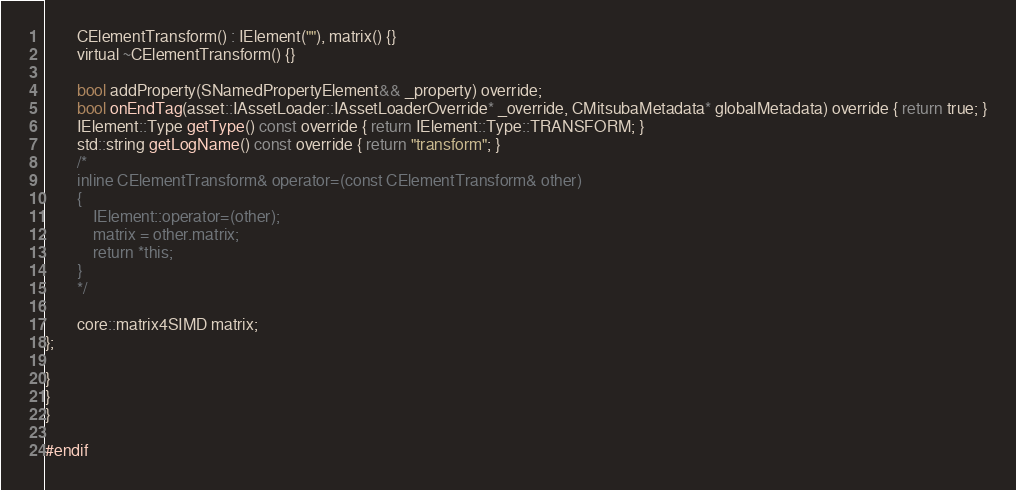<code> <loc_0><loc_0><loc_500><loc_500><_C_>		CElementTransform() : IElement(""), matrix() {}
		virtual ~CElementTransform() {}

		bool addProperty(SNamedPropertyElement&& _property) override;
		bool onEndTag(asset::IAssetLoader::IAssetLoaderOverride* _override, CMitsubaMetadata* globalMetadata) override { return true; }
		IElement::Type getType() const override { return IElement::Type::TRANSFORM; }
		std::string getLogName() const override { return "transform"; }
		/*
		inline CElementTransform& operator=(const CElementTransform& other)
		{
			IElement::operator=(other);
			matrix = other.matrix;
			return *this;
		}
		*/

		core::matrix4SIMD matrix;
};

}
}
}

#endif</code> 